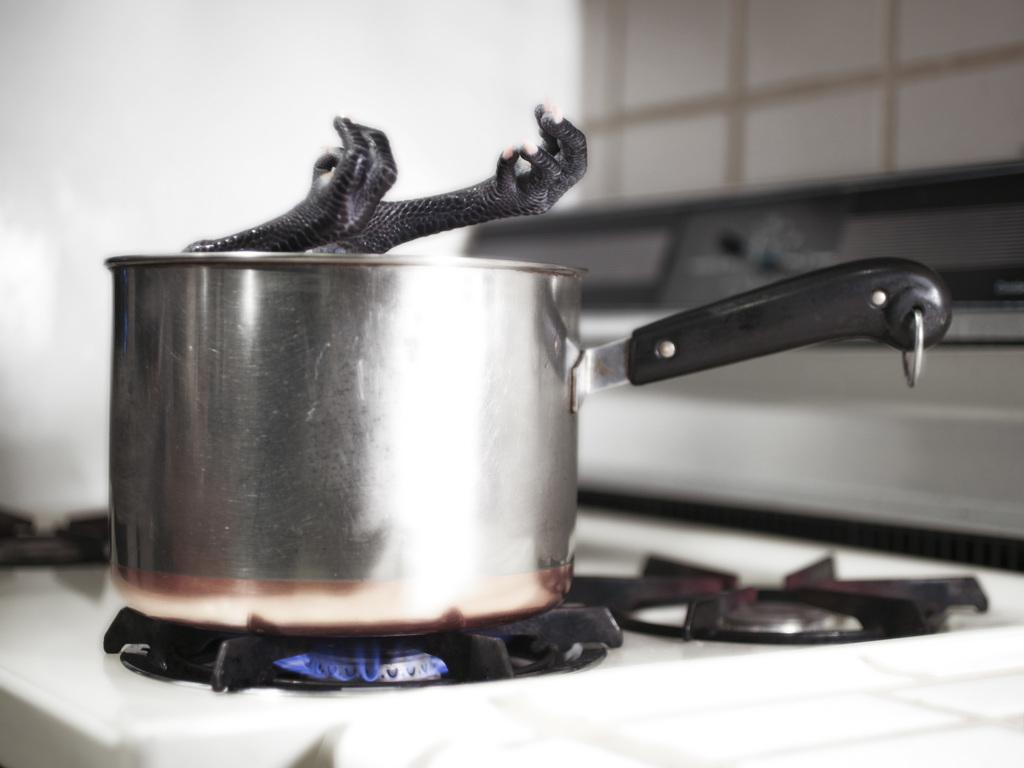What is the main object in the image? There is a saucepan in the image. Where is the saucepan located? The saucepan is placed on a stove. What is inside the saucepan? There is an object placed in the saucepan. What else can be seen in the image? There are other objects visible in the background of the image. Can you tell me how many pieces of cheese are on the woman's plate in the image? There is no woman or cheese present in the image. What type of basin is visible in the image? There is no basin present in the image. 